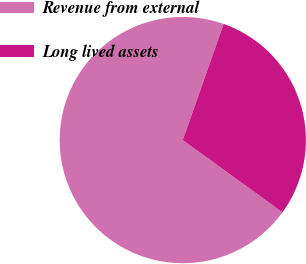<chart> <loc_0><loc_0><loc_500><loc_500><pie_chart><fcel>Revenue from external<fcel>Long lived assets<nl><fcel>70.4%<fcel>29.6%<nl></chart> 